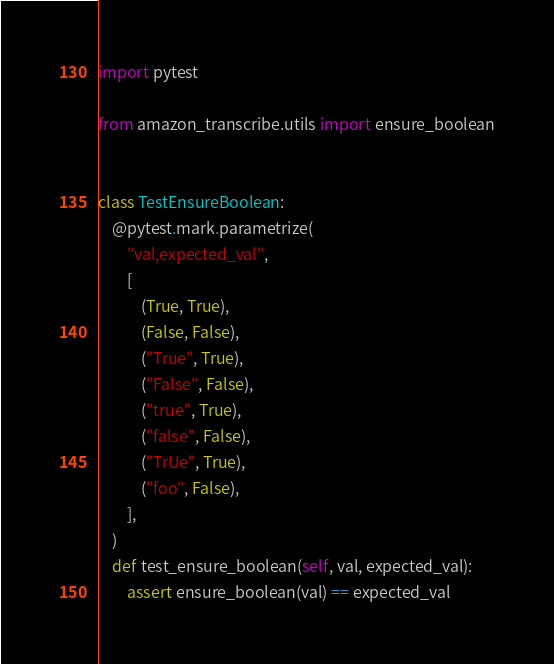Convert code to text. <code><loc_0><loc_0><loc_500><loc_500><_Python_>import pytest

from amazon_transcribe.utils import ensure_boolean


class TestEnsureBoolean:
    @pytest.mark.parametrize(
        "val,expected_val",
        [
            (True, True),
            (False, False),
            ("True", True),
            ("False", False),
            ("true", True),
            ("false", False),
            ("TrUe", True),
            ("foo", False),
        ],
    )
    def test_ensure_boolean(self, val, expected_val):
        assert ensure_boolean(val) == expected_val
</code> 